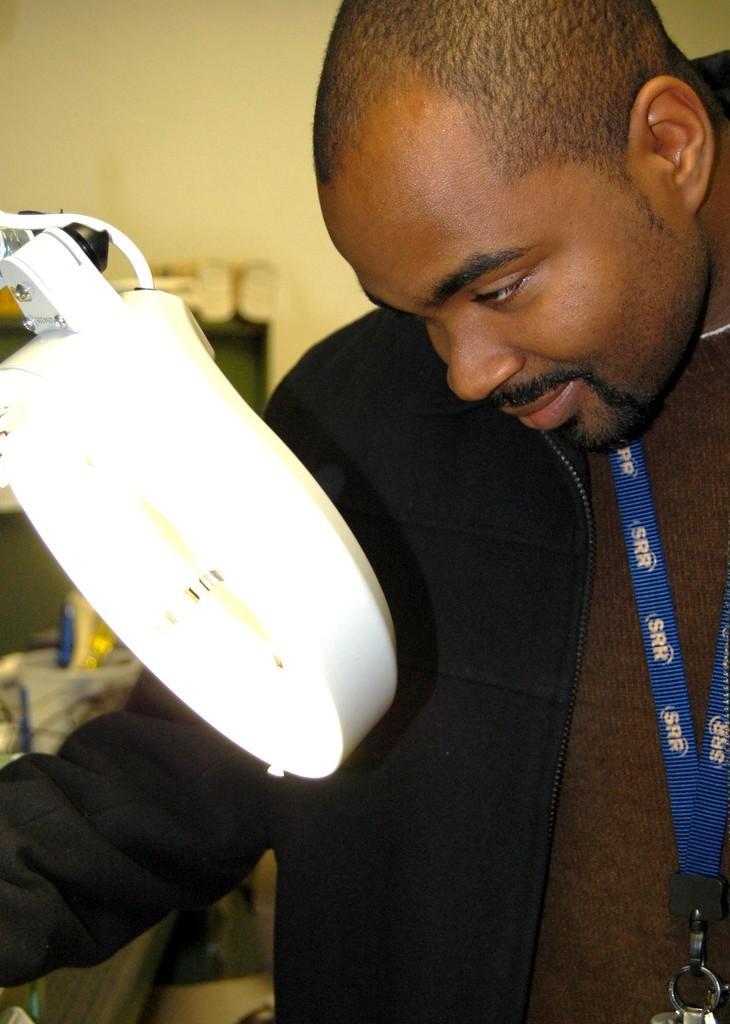How would you summarize this image in a sentence or two? In this picture we can see the man wearing black shirt, standing in the front. Beside there is a white table light. Behind we can see the yellow wall. 